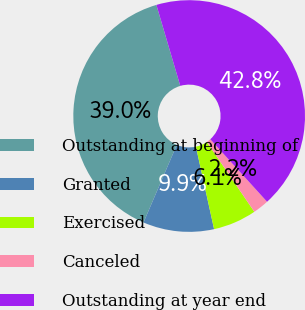<chart> <loc_0><loc_0><loc_500><loc_500><pie_chart><fcel>Outstanding at beginning of<fcel>Granted<fcel>Exercised<fcel>Canceled<fcel>Outstanding at year end<nl><fcel>38.99%<fcel>9.9%<fcel>6.06%<fcel>2.23%<fcel>42.83%<nl></chart> 